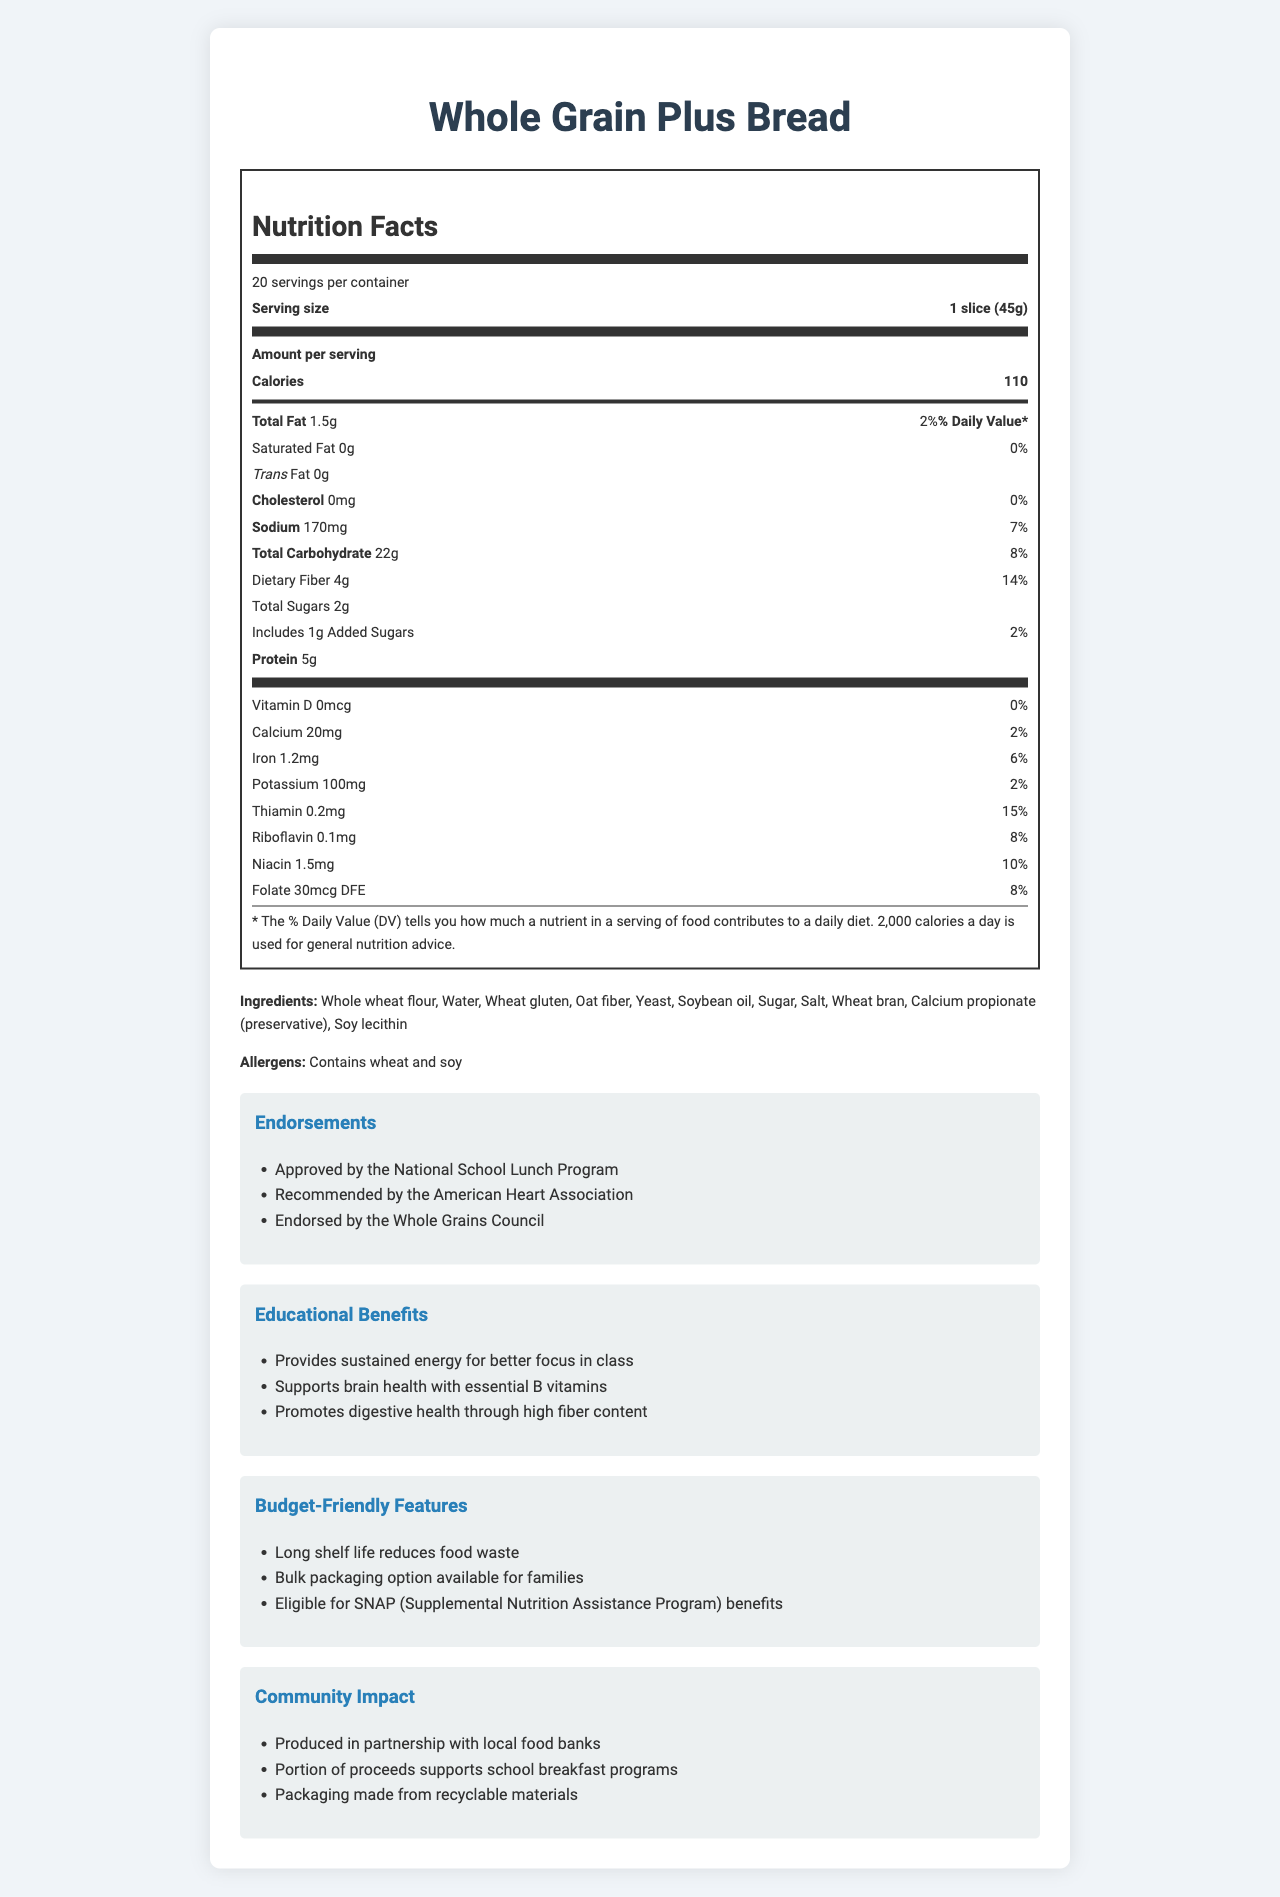what is the serving size of Whole Grain Plus Bread? The serving size is explicitly mentioned at the top of the nutrition label.
Answer: 1 slice (45g) how many calories are in one serving? The number of calories per serving is stated as 110 in the nutrition label under "Amount per serving."
Answer: 110 how much dietary fiber is in one slice? The dietary fiber content per serving is listed as 4g in the nutrition label.
Answer: 4g which two vitamins have the highest daily value percentages? The daily value percentages listed are 15% for Thiamin and 10% for Niacin, which are the highest among the vitamins and minerals listed.
Answer: Thiamin (15%), Niacin (10%) What are the budget-friendly features of the Whole Grain Plus Bread? These features are listed under the budget-friendly features section.
Answer: Long shelf life reduces food waste, Bulk packaging option available for families, Eligible for SNAP benefits how many servings are there in one container? This information is listed at the top of the nutrition label under "20 servings per container."
Answer: 20 what endorsements does this bread have? The endorsements are mentioned in the endorsements section of the document.
Answer: Approved by the National School Lunch Program, Recommended by the American Heart Association, Endorsed by the Whole Grains Council are there any trans fats in this bread? The document clearly mentions that the trans fat content is 0g.
Answer: No which of the following is not an ingredient in the Whole Grain Plus Bread? A. Soybean oil B. High fructose corn syrup C. Wheat bran D. Yeast The listed ingredients do not include high fructose corn syrup.
Answer: B. High fructose corn syrup What are the allergens present in this bread? The allergens section specifies that the bread contains wheat and soy.
Answer: Wheat and soy does the bread provide any educational benefits? There are educational benefits listed, such as providing sustained energy for better focus in class, supporting brain health with essential B vitamins, and promoting digestive health through high fiber content.
Answer: Yes summarize the main benefits and features of the Whole Grain Plus Bread as described in the document. The document provides detailed information on nutritional content, endorsements, benefits for education and budget, and the impact on the community. The bread is high in fiber, has a long shelf life, available for bulk buying, and supports several social programs.
Answer: The bread provides high nutritional value with 110 calories per slice, 4g of dietary fiber, and is rich in essential B vitamins. It has several endorsements, educational benefits, budget-friendly features, and positive community impact. what is the recommended dietary fiber daily value percentage per serving? The daily value percentage for dietary fiber is listed as 14% per serving.
Answer: 14% what is the amount of calcium in one serving? The nutrition label lists 20mg of calcium per serving.
Answer: 20mg what part of the document states the community impact of the bread? The community impact is described in a dedicated section titled "Community Impact."
Answer: The "Community Impact" section how many grams of total sugars are included in one serving? The total sugars in one slice are listed as 2g on the nutrition label.
Answer: 2g how is the packaging of the bread environmentally friendly? The community impact section mentions that the packaging is made from recyclable materials.
Answer: Packaging made from recyclable materials why is this bread a good choice for families on a budget? These are the budget-friendly features listed in the document.
Answer: Long shelf life reduces food waste, Bulk packaging option available, Eligible for SNAP benefits what would be the benefit of the bread being approved by the National School Lunch Program? The endorsement by the National School Lunch Program means the bread conforms to nutritional guidelines necessary for school meals.
Answer: It ensures the bread meets nutritional standards for school meals and can be included in school lunch programs. are artificial preservatives included in the Whole Grain Plus Bread? There is no specific mention about artificial preservatives; only calcium propionate is listed which is not enough to determine if it is considered artificial or not.
Answer: Not enough information how much niacin is in one serving? The nutrition label shows that there is 1.5mg of niacin in each serving.
Answer: 1.5mg what is the amount of sodium in a single serving? The amount of sodium per serving is listed as 170mg in the nutrition label.
Answer: 170mg 